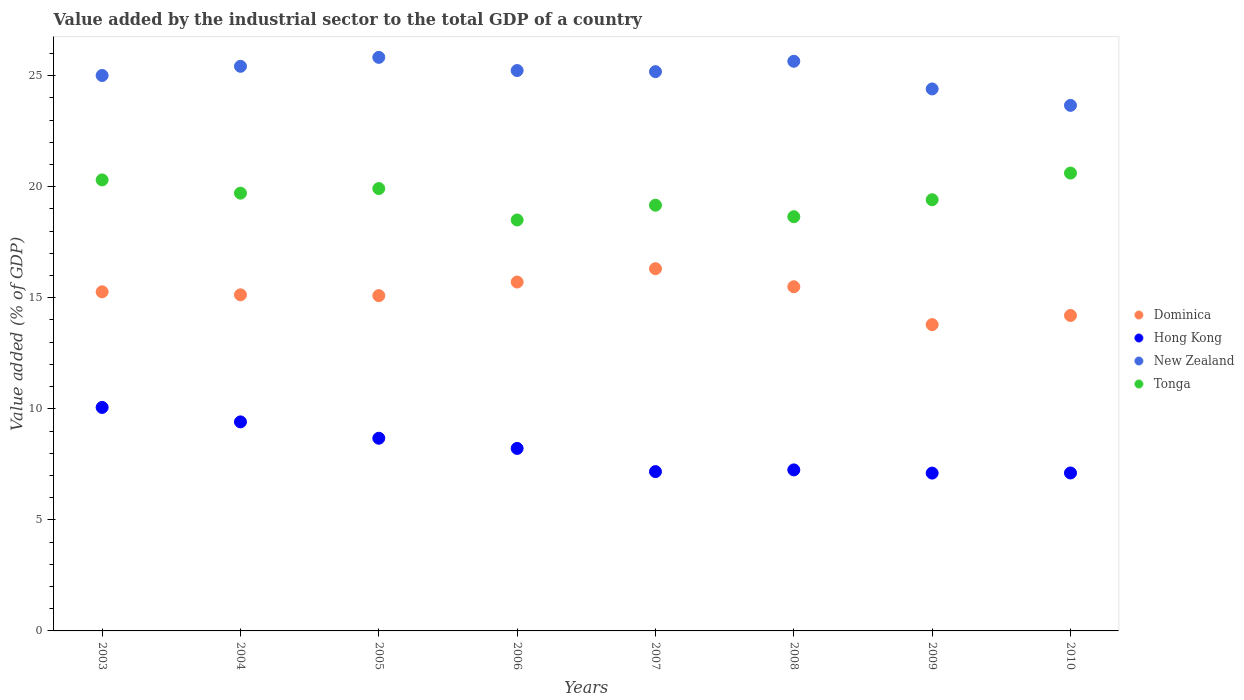What is the value added by the industrial sector to the total GDP in Dominica in 2004?
Provide a succinct answer. 15.13. Across all years, what is the maximum value added by the industrial sector to the total GDP in Dominica?
Your answer should be compact. 16.31. Across all years, what is the minimum value added by the industrial sector to the total GDP in Tonga?
Ensure brevity in your answer.  18.5. In which year was the value added by the industrial sector to the total GDP in New Zealand maximum?
Your answer should be compact. 2005. What is the total value added by the industrial sector to the total GDP in Dominica in the graph?
Your response must be concise. 120.99. What is the difference between the value added by the industrial sector to the total GDP in Dominica in 2008 and that in 2009?
Make the answer very short. 1.7. What is the difference between the value added by the industrial sector to the total GDP in Hong Kong in 2003 and the value added by the industrial sector to the total GDP in New Zealand in 2010?
Give a very brief answer. -13.6. What is the average value added by the industrial sector to the total GDP in New Zealand per year?
Make the answer very short. 25.04. In the year 2007, what is the difference between the value added by the industrial sector to the total GDP in New Zealand and value added by the industrial sector to the total GDP in Hong Kong?
Your answer should be compact. 18.01. What is the ratio of the value added by the industrial sector to the total GDP in Tonga in 2005 to that in 2006?
Offer a terse response. 1.08. Is the value added by the industrial sector to the total GDP in Tonga in 2005 less than that in 2009?
Your answer should be compact. No. Is the difference between the value added by the industrial sector to the total GDP in New Zealand in 2003 and 2008 greater than the difference between the value added by the industrial sector to the total GDP in Hong Kong in 2003 and 2008?
Keep it short and to the point. No. What is the difference between the highest and the second highest value added by the industrial sector to the total GDP in Dominica?
Provide a short and direct response. 0.6. What is the difference between the highest and the lowest value added by the industrial sector to the total GDP in Tonga?
Your response must be concise. 2.11. In how many years, is the value added by the industrial sector to the total GDP in Tonga greater than the average value added by the industrial sector to the total GDP in Tonga taken over all years?
Provide a succinct answer. 4. Is it the case that in every year, the sum of the value added by the industrial sector to the total GDP in Dominica and value added by the industrial sector to the total GDP in Hong Kong  is greater than the value added by the industrial sector to the total GDP in New Zealand?
Provide a short and direct response. No. Is the value added by the industrial sector to the total GDP in Tonga strictly greater than the value added by the industrial sector to the total GDP in Dominica over the years?
Keep it short and to the point. Yes. Is the value added by the industrial sector to the total GDP in New Zealand strictly less than the value added by the industrial sector to the total GDP in Dominica over the years?
Keep it short and to the point. No. How many dotlines are there?
Give a very brief answer. 4. How many years are there in the graph?
Keep it short and to the point. 8. What is the difference between two consecutive major ticks on the Y-axis?
Offer a very short reply. 5. Are the values on the major ticks of Y-axis written in scientific E-notation?
Provide a succinct answer. No. Does the graph contain grids?
Provide a short and direct response. No. How many legend labels are there?
Provide a succinct answer. 4. How are the legend labels stacked?
Keep it short and to the point. Vertical. What is the title of the graph?
Your response must be concise. Value added by the industrial sector to the total GDP of a country. Does "Equatorial Guinea" appear as one of the legend labels in the graph?
Provide a succinct answer. No. What is the label or title of the X-axis?
Your answer should be compact. Years. What is the label or title of the Y-axis?
Provide a succinct answer. Value added (% of GDP). What is the Value added (% of GDP) of Dominica in 2003?
Provide a succinct answer. 15.27. What is the Value added (% of GDP) in Hong Kong in 2003?
Provide a short and direct response. 10.06. What is the Value added (% of GDP) in New Zealand in 2003?
Keep it short and to the point. 25.01. What is the Value added (% of GDP) in Tonga in 2003?
Your answer should be compact. 20.3. What is the Value added (% of GDP) in Dominica in 2004?
Offer a terse response. 15.13. What is the Value added (% of GDP) of Hong Kong in 2004?
Your answer should be compact. 9.41. What is the Value added (% of GDP) in New Zealand in 2004?
Give a very brief answer. 25.42. What is the Value added (% of GDP) of Tonga in 2004?
Your response must be concise. 19.71. What is the Value added (% of GDP) in Dominica in 2005?
Offer a terse response. 15.09. What is the Value added (% of GDP) of Hong Kong in 2005?
Offer a terse response. 8.67. What is the Value added (% of GDP) in New Zealand in 2005?
Make the answer very short. 25.82. What is the Value added (% of GDP) of Tonga in 2005?
Give a very brief answer. 19.92. What is the Value added (% of GDP) of Dominica in 2006?
Give a very brief answer. 15.71. What is the Value added (% of GDP) in Hong Kong in 2006?
Ensure brevity in your answer.  8.22. What is the Value added (% of GDP) of New Zealand in 2006?
Your answer should be compact. 25.23. What is the Value added (% of GDP) in Tonga in 2006?
Offer a terse response. 18.5. What is the Value added (% of GDP) in Dominica in 2007?
Give a very brief answer. 16.31. What is the Value added (% of GDP) of Hong Kong in 2007?
Provide a succinct answer. 7.17. What is the Value added (% of GDP) of New Zealand in 2007?
Ensure brevity in your answer.  25.18. What is the Value added (% of GDP) of Tonga in 2007?
Your response must be concise. 19.17. What is the Value added (% of GDP) of Dominica in 2008?
Give a very brief answer. 15.49. What is the Value added (% of GDP) in Hong Kong in 2008?
Ensure brevity in your answer.  7.25. What is the Value added (% of GDP) of New Zealand in 2008?
Your answer should be compact. 25.65. What is the Value added (% of GDP) in Tonga in 2008?
Offer a very short reply. 18.65. What is the Value added (% of GDP) of Dominica in 2009?
Make the answer very short. 13.79. What is the Value added (% of GDP) in Hong Kong in 2009?
Provide a short and direct response. 7.11. What is the Value added (% of GDP) in New Zealand in 2009?
Offer a very short reply. 24.4. What is the Value added (% of GDP) of Tonga in 2009?
Give a very brief answer. 19.41. What is the Value added (% of GDP) in Dominica in 2010?
Give a very brief answer. 14.2. What is the Value added (% of GDP) of Hong Kong in 2010?
Make the answer very short. 7.11. What is the Value added (% of GDP) in New Zealand in 2010?
Provide a succinct answer. 23.66. What is the Value added (% of GDP) of Tonga in 2010?
Provide a short and direct response. 20.61. Across all years, what is the maximum Value added (% of GDP) of Dominica?
Your answer should be very brief. 16.31. Across all years, what is the maximum Value added (% of GDP) of Hong Kong?
Your response must be concise. 10.06. Across all years, what is the maximum Value added (% of GDP) of New Zealand?
Offer a terse response. 25.82. Across all years, what is the maximum Value added (% of GDP) in Tonga?
Provide a succinct answer. 20.61. Across all years, what is the minimum Value added (% of GDP) of Dominica?
Provide a succinct answer. 13.79. Across all years, what is the minimum Value added (% of GDP) in Hong Kong?
Provide a short and direct response. 7.11. Across all years, what is the minimum Value added (% of GDP) in New Zealand?
Give a very brief answer. 23.66. Across all years, what is the minimum Value added (% of GDP) of Tonga?
Make the answer very short. 18.5. What is the total Value added (% of GDP) of Dominica in the graph?
Your response must be concise. 120.99. What is the total Value added (% of GDP) of Hong Kong in the graph?
Your answer should be compact. 65. What is the total Value added (% of GDP) in New Zealand in the graph?
Your response must be concise. 200.36. What is the total Value added (% of GDP) in Tonga in the graph?
Offer a very short reply. 156.27. What is the difference between the Value added (% of GDP) in Dominica in 2003 and that in 2004?
Your answer should be compact. 0.14. What is the difference between the Value added (% of GDP) of Hong Kong in 2003 and that in 2004?
Offer a very short reply. 0.65. What is the difference between the Value added (% of GDP) of New Zealand in 2003 and that in 2004?
Keep it short and to the point. -0.41. What is the difference between the Value added (% of GDP) in Tonga in 2003 and that in 2004?
Ensure brevity in your answer.  0.6. What is the difference between the Value added (% of GDP) in Dominica in 2003 and that in 2005?
Your answer should be compact. 0.17. What is the difference between the Value added (% of GDP) in Hong Kong in 2003 and that in 2005?
Ensure brevity in your answer.  1.39. What is the difference between the Value added (% of GDP) of New Zealand in 2003 and that in 2005?
Your answer should be very brief. -0.82. What is the difference between the Value added (% of GDP) in Tonga in 2003 and that in 2005?
Offer a very short reply. 0.39. What is the difference between the Value added (% of GDP) of Dominica in 2003 and that in 2006?
Offer a very short reply. -0.44. What is the difference between the Value added (% of GDP) in Hong Kong in 2003 and that in 2006?
Give a very brief answer. 1.85. What is the difference between the Value added (% of GDP) of New Zealand in 2003 and that in 2006?
Offer a very short reply. -0.22. What is the difference between the Value added (% of GDP) of Tonga in 2003 and that in 2006?
Provide a succinct answer. 1.8. What is the difference between the Value added (% of GDP) in Dominica in 2003 and that in 2007?
Your response must be concise. -1.04. What is the difference between the Value added (% of GDP) of Hong Kong in 2003 and that in 2007?
Make the answer very short. 2.89. What is the difference between the Value added (% of GDP) in New Zealand in 2003 and that in 2007?
Provide a short and direct response. -0.17. What is the difference between the Value added (% of GDP) of Tonga in 2003 and that in 2007?
Make the answer very short. 1.14. What is the difference between the Value added (% of GDP) in Dominica in 2003 and that in 2008?
Keep it short and to the point. -0.23. What is the difference between the Value added (% of GDP) of Hong Kong in 2003 and that in 2008?
Your response must be concise. 2.81. What is the difference between the Value added (% of GDP) in New Zealand in 2003 and that in 2008?
Keep it short and to the point. -0.64. What is the difference between the Value added (% of GDP) in Tonga in 2003 and that in 2008?
Offer a very short reply. 1.66. What is the difference between the Value added (% of GDP) in Dominica in 2003 and that in 2009?
Your answer should be compact. 1.48. What is the difference between the Value added (% of GDP) in Hong Kong in 2003 and that in 2009?
Ensure brevity in your answer.  2.96. What is the difference between the Value added (% of GDP) of New Zealand in 2003 and that in 2009?
Ensure brevity in your answer.  0.61. What is the difference between the Value added (% of GDP) in Tonga in 2003 and that in 2009?
Your response must be concise. 0.89. What is the difference between the Value added (% of GDP) of Dominica in 2003 and that in 2010?
Ensure brevity in your answer.  1.07. What is the difference between the Value added (% of GDP) of Hong Kong in 2003 and that in 2010?
Give a very brief answer. 2.95. What is the difference between the Value added (% of GDP) of New Zealand in 2003 and that in 2010?
Provide a short and direct response. 1.34. What is the difference between the Value added (% of GDP) in Tonga in 2003 and that in 2010?
Your answer should be very brief. -0.31. What is the difference between the Value added (% of GDP) of Dominica in 2004 and that in 2005?
Provide a short and direct response. 0.04. What is the difference between the Value added (% of GDP) of Hong Kong in 2004 and that in 2005?
Provide a short and direct response. 0.74. What is the difference between the Value added (% of GDP) of New Zealand in 2004 and that in 2005?
Provide a short and direct response. -0.4. What is the difference between the Value added (% of GDP) in Tonga in 2004 and that in 2005?
Offer a terse response. -0.21. What is the difference between the Value added (% of GDP) in Dominica in 2004 and that in 2006?
Provide a succinct answer. -0.58. What is the difference between the Value added (% of GDP) of Hong Kong in 2004 and that in 2006?
Give a very brief answer. 1.19. What is the difference between the Value added (% of GDP) in New Zealand in 2004 and that in 2006?
Offer a terse response. 0.19. What is the difference between the Value added (% of GDP) of Tonga in 2004 and that in 2006?
Give a very brief answer. 1.21. What is the difference between the Value added (% of GDP) of Dominica in 2004 and that in 2007?
Provide a short and direct response. -1.18. What is the difference between the Value added (% of GDP) of Hong Kong in 2004 and that in 2007?
Your answer should be compact. 2.24. What is the difference between the Value added (% of GDP) of New Zealand in 2004 and that in 2007?
Your response must be concise. 0.24. What is the difference between the Value added (% of GDP) in Tonga in 2004 and that in 2007?
Your answer should be very brief. 0.54. What is the difference between the Value added (% of GDP) in Dominica in 2004 and that in 2008?
Make the answer very short. -0.36. What is the difference between the Value added (% of GDP) in Hong Kong in 2004 and that in 2008?
Your answer should be very brief. 2.16. What is the difference between the Value added (% of GDP) in New Zealand in 2004 and that in 2008?
Your response must be concise. -0.23. What is the difference between the Value added (% of GDP) in Tonga in 2004 and that in 2008?
Provide a short and direct response. 1.06. What is the difference between the Value added (% of GDP) of Dominica in 2004 and that in 2009?
Offer a terse response. 1.34. What is the difference between the Value added (% of GDP) in Hong Kong in 2004 and that in 2009?
Provide a short and direct response. 2.31. What is the difference between the Value added (% of GDP) in New Zealand in 2004 and that in 2009?
Offer a very short reply. 1.02. What is the difference between the Value added (% of GDP) of Tonga in 2004 and that in 2009?
Your answer should be very brief. 0.3. What is the difference between the Value added (% of GDP) in Dominica in 2004 and that in 2010?
Offer a terse response. 0.93. What is the difference between the Value added (% of GDP) in New Zealand in 2004 and that in 2010?
Provide a succinct answer. 1.76. What is the difference between the Value added (% of GDP) of Tonga in 2004 and that in 2010?
Give a very brief answer. -0.9. What is the difference between the Value added (% of GDP) in Dominica in 2005 and that in 2006?
Ensure brevity in your answer.  -0.61. What is the difference between the Value added (% of GDP) of Hong Kong in 2005 and that in 2006?
Make the answer very short. 0.46. What is the difference between the Value added (% of GDP) of New Zealand in 2005 and that in 2006?
Ensure brevity in your answer.  0.59. What is the difference between the Value added (% of GDP) in Tonga in 2005 and that in 2006?
Ensure brevity in your answer.  1.42. What is the difference between the Value added (% of GDP) in Dominica in 2005 and that in 2007?
Offer a very short reply. -1.21. What is the difference between the Value added (% of GDP) in Hong Kong in 2005 and that in 2007?
Give a very brief answer. 1.5. What is the difference between the Value added (% of GDP) of New Zealand in 2005 and that in 2007?
Offer a terse response. 0.64. What is the difference between the Value added (% of GDP) of Tonga in 2005 and that in 2007?
Offer a very short reply. 0.75. What is the difference between the Value added (% of GDP) of Dominica in 2005 and that in 2008?
Give a very brief answer. -0.4. What is the difference between the Value added (% of GDP) of Hong Kong in 2005 and that in 2008?
Provide a short and direct response. 1.43. What is the difference between the Value added (% of GDP) of New Zealand in 2005 and that in 2008?
Provide a succinct answer. 0.18. What is the difference between the Value added (% of GDP) of Tonga in 2005 and that in 2008?
Your answer should be very brief. 1.27. What is the difference between the Value added (% of GDP) of Dominica in 2005 and that in 2009?
Provide a succinct answer. 1.3. What is the difference between the Value added (% of GDP) of Hong Kong in 2005 and that in 2009?
Your answer should be compact. 1.57. What is the difference between the Value added (% of GDP) of New Zealand in 2005 and that in 2009?
Give a very brief answer. 1.42. What is the difference between the Value added (% of GDP) in Tonga in 2005 and that in 2009?
Ensure brevity in your answer.  0.5. What is the difference between the Value added (% of GDP) in Dominica in 2005 and that in 2010?
Your answer should be compact. 0.89. What is the difference between the Value added (% of GDP) of Hong Kong in 2005 and that in 2010?
Offer a very short reply. 1.56. What is the difference between the Value added (% of GDP) in New Zealand in 2005 and that in 2010?
Provide a short and direct response. 2.16. What is the difference between the Value added (% of GDP) of Tonga in 2005 and that in 2010?
Your answer should be compact. -0.7. What is the difference between the Value added (% of GDP) of Dominica in 2006 and that in 2007?
Your response must be concise. -0.6. What is the difference between the Value added (% of GDP) in Hong Kong in 2006 and that in 2007?
Your response must be concise. 1.04. What is the difference between the Value added (% of GDP) in New Zealand in 2006 and that in 2007?
Provide a short and direct response. 0.05. What is the difference between the Value added (% of GDP) in Tonga in 2006 and that in 2007?
Ensure brevity in your answer.  -0.67. What is the difference between the Value added (% of GDP) of Dominica in 2006 and that in 2008?
Offer a terse response. 0.21. What is the difference between the Value added (% of GDP) of New Zealand in 2006 and that in 2008?
Make the answer very short. -0.42. What is the difference between the Value added (% of GDP) in Tonga in 2006 and that in 2008?
Offer a terse response. -0.15. What is the difference between the Value added (% of GDP) in Dominica in 2006 and that in 2009?
Your answer should be compact. 1.92. What is the difference between the Value added (% of GDP) of Hong Kong in 2006 and that in 2009?
Give a very brief answer. 1.11. What is the difference between the Value added (% of GDP) in New Zealand in 2006 and that in 2009?
Offer a very short reply. 0.83. What is the difference between the Value added (% of GDP) in Tonga in 2006 and that in 2009?
Offer a very short reply. -0.91. What is the difference between the Value added (% of GDP) of Dominica in 2006 and that in 2010?
Offer a terse response. 1.51. What is the difference between the Value added (% of GDP) in Hong Kong in 2006 and that in 2010?
Your answer should be very brief. 1.11. What is the difference between the Value added (% of GDP) of New Zealand in 2006 and that in 2010?
Provide a short and direct response. 1.57. What is the difference between the Value added (% of GDP) in Tonga in 2006 and that in 2010?
Offer a very short reply. -2.11. What is the difference between the Value added (% of GDP) of Dominica in 2007 and that in 2008?
Offer a very short reply. 0.81. What is the difference between the Value added (% of GDP) in Hong Kong in 2007 and that in 2008?
Your response must be concise. -0.08. What is the difference between the Value added (% of GDP) of New Zealand in 2007 and that in 2008?
Provide a succinct answer. -0.47. What is the difference between the Value added (% of GDP) in Tonga in 2007 and that in 2008?
Your response must be concise. 0.52. What is the difference between the Value added (% of GDP) of Dominica in 2007 and that in 2009?
Your response must be concise. 2.52. What is the difference between the Value added (% of GDP) in Hong Kong in 2007 and that in 2009?
Give a very brief answer. 0.07. What is the difference between the Value added (% of GDP) of New Zealand in 2007 and that in 2009?
Give a very brief answer. 0.78. What is the difference between the Value added (% of GDP) of Tonga in 2007 and that in 2009?
Your answer should be very brief. -0.25. What is the difference between the Value added (% of GDP) in Dominica in 2007 and that in 2010?
Provide a short and direct response. 2.11. What is the difference between the Value added (% of GDP) of Hong Kong in 2007 and that in 2010?
Offer a terse response. 0.06. What is the difference between the Value added (% of GDP) in New Zealand in 2007 and that in 2010?
Your response must be concise. 1.52. What is the difference between the Value added (% of GDP) of Tonga in 2007 and that in 2010?
Your answer should be very brief. -1.45. What is the difference between the Value added (% of GDP) of Dominica in 2008 and that in 2009?
Provide a succinct answer. 1.7. What is the difference between the Value added (% of GDP) of Hong Kong in 2008 and that in 2009?
Your answer should be very brief. 0.14. What is the difference between the Value added (% of GDP) in New Zealand in 2008 and that in 2009?
Ensure brevity in your answer.  1.25. What is the difference between the Value added (% of GDP) of Tonga in 2008 and that in 2009?
Provide a succinct answer. -0.76. What is the difference between the Value added (% of GDP) in Dominica in 2008 and that in 2010?
Provide a short and direct response. 1.29. What is the difference between the Value added (% of GDP) in Hong Kong in 2008 and that in 2010?
Give a very brief answer. 0.14. What is the difference between the Value added (% of GDP) of New Zealand in 2008 and that in 2010?
Keep it short and to the point. 1.98. What is the difference between the Value added (% of GDP) in Tonga in 2008 and that in 2010?
Offer a very short reply. -1.96. What is the difference between the Value added (% of GDP) of Dominica in 2009 and that in 2010?
Ensure brevity in your answer.  -0.41. What is the difference between the Value added (% of GDP) of Hong Kong in 2009 and that in 2010?
Offer a terse response. -0.01. What is the difference between the Value added (% of GDP) in New Zealand in 2009 and that in 2010?
Your response must be concise. 0.74. What is the difference between the Value added (% of GDP) of Tonga in 2009 and that in 2010?
Provide a succinct answer. -1.2. What is the difference between the Value added (% of GDP) in Dominica in 2003 and the Value added (% of GDP) in Hong Kong in 2004?
Offer a terse response. 5.86. What is the difference between the Value added (% of GDP) of Dominica in 2003 and the Value added (% of GDP) of New Zealand in 2004?
Your answer should be compact. -10.15. What is the difference between the Value added (% of GDP) of Dominica in 2003 and the Value added (% of GDP) of Tonga in 2004?
Make the answer very short. -4.44. What is the difference between the Value added (% of GDP) of Hong Kong in 2003 and the Value added (% of GDP) of New Zealand in 2004?
Ensure brevity in your answer.  -15.36. What is the difference between the Value added (% of GDP) of Hong Kong in 2003 and the Value added (% of GDP) of Tonga in 2004?
Offer a very short reply. -9.65. What is the difference between the Value added (% of GDP) in New Zealand in 2003 and the Value added (% of GDP) in Tonga in 2004?
Your answer should be very brief. 5.3. What is the difference between the Value added (% of GDP) of Dominica in 2003 and the Value added (% of GDP) of Hong Kong in 2005?
Ensure brevity in your answer.  6.59. What is the difference between the Value added (% of GDP) of Dominica in 2003 and the Value added (% of GDP) of New Zealand in 2005?
Make the answer very short. -10.56. What is the difference between the Value added (% of GDP) in Dominica in 2003 and the Value added (% of GDP) in Tonga in 2005?
Your answer should be very brief. -4.65. What is the difference between the Value added (% of GDP) of Hong Kong in 2003 and the Value added (% of GDP) of New Zealand in 2005?
Your answer should be very brief. -15.76. What is the difference between the Value added (% of GDP) of Hong Kong in 2003 and the Value added (% of GDP) of Tonga in 2005?
Give a very brief answer. -9.85. What is the difference between the Value added (% of GDP) of New Zealand in 2003 and the Value added (% of GDP) of Tonga in 2005?
Your answer should be very brief. 5.09. What is the difference between the Value added (% of GDP) in Dominica in 2003 and the Value added (% of GDP) in Hong Kong in 2006?
Offer a very short reply. 7.05. What is the difference between the Value added (% of GDP) in Dominica in 2003 and the Value added (% of GDP) in New Zealand in 2006?
Offer a terse response. -9.96. What is the difference between the Value added (% of GDP) of Dominica in 2003 and the Value added (% of GDP) of Tonga in 2006?
Your answer should be compact. -3.23. What is the difference between the Value added (% of GDP) of Hong Kong in 2003 and the Value added (% of GDP) of New Zealand in 2006?
Provide a short and direct response. -15.17. What is the difference between the Value added (% of GDP) in Hong Kong in 2003 and the Value added (% of GDP) in Tonga in 2006?
Your answer should be very brief. -8.44. What is the difference between the Value added (% of GDP) of New Zealand in 2003 and the Value added (% of GDP) of Tonga in 2006?
Offer a terse response. 6.5. What is the difference between the Value added (% of GDP) in Dominica in 2003 and the Value added (% of GDP) in Hong Kong in 2007?
Make the answer very short. 8.09. What is the difference between the Value added (% of GDP) of Dominica in 2003 and the Value added (% of GDP) of New Zealand in 2007?
Your answer should be very brief. -9.91. What is the difference between the Value added (% of GDP) in Dominica in 2003 and the Value added (% of GDP) in Tonga in 2007?
Make the answer very short. -3.9. What is the difference between the Value added (% of GDP) of Hong Kong in 2003 and the Value added (% of GDP) of New Zealand in 2007?
Provide a short and direct response. -15.12. What is the difference between the Value added (% of GDP) of Hong Kong in 2003 and the Value added (% of GDP) of Tonga in 2007?
Ensure brevity in your answer.  -9.1. What is the difference between the Value added (% of GDP) of New Zealand in 2003 and the Value added (% of GDP) of Tonga in 2007?
Ensure brevity in your answer.  5.84. What is the difference between the Value added (% of GDP) in Dominica in 2003 and the Value added (% of GDP) in Hong Kong in 2008?
Offer a terse response. 8.02. What is the difference between the Value added (% of GDP) of Dominica in 2003 and the Value added (% of GDP) of New Zealand in 2008?
Your response must be concise. -10.38. What is the difference between the Value added (% of GDP) in Dominica in 2003 and the Value added (% of GDP) in Tonga in 2008?
Your answer should be compact. -3.38. What is the difference between the Value added (% of GDP) in Hong Kong in 2003 and the Value added (% of GDP) in New Zealand in 2008?
Ensure brevity in your answer.  -15.58. What is the difference between the Value added (% of GDP) in Hong Kong in 2003 and the Value added (% of GDP) in Tonga in 2008?
Your answer should be very brief. -8.59. What is the difference between the Value added (% of GDP) of New Zealand in 2003 and the Value added (% of GDP) of Tonga in 2008?
Keep it short and to the point. 6.36. What is the difference between the Value added (% of GDP) in Dominica in 2003 and the Value added (% of GDP) in Hong Kong in 2009?
Provide a short and direct response. 8.16. What is the difference between the Value added (% of GDP) in Dominica in 2003 and the Value added (% of GDP) in New Zealand in 2009?
Give a very brief answer. -9.13. What is the difference between the Value added (% of GDP) of Dominica in 2003 and the Value added (% of GDP) of Tonga in 2009?
Offer a terse response. -4.15. What is the difference between the Value added (% of GDP) in Hong Kong in 2003 and the Value added (% of GDP) in New Zealand in 2009?
Ensure brevity in your answer.  -14.34. What is the difference between the Value added (% of GDP) in Hong Kong in 2003 and the Value added (% of GDP) in Tonga in 2009?
Your answer should be very brief. -9.35. What is the difference between the Value added (% of GDP) in New Zealand in 2003 and the Value added (% of GDP) in Tonga in 2009?
Keep it short and to the point. 5.59. What is the difference between the Value added (% of GDP) in Dominica in 2003 and the Value added (% of GDP) in Hong Kong in 2010?
Provide a succinct answer. 8.16. What is the difference between the Value added (% of GDP) of Dominica in 2003 and the Value added (% of GDP) of New Zealand in 2010?
Your answer should be compact. -8.39. What is the difference between the Value added (% of GDP) in Dominica in 2003 and the Value added (% of GDP) in Tonga in 2010?
Your answer should be compact. -5.35. What is the difference between the Value added (% of GDP) of Hong Kong in 2003 and the Value added (% of GDP) of New Zealand in 2010?
Provide a short and direct response. -13.6. What is the difference between the Value added (% of GDP) of Hong Kong in 2003 and the Value added (% of GDP) of Tonga in 2010?
Your answer should be very brief. -10.55. What is the difference between the Value added (% of GDP) of New Zealand in 2003 and the Value added (% of GDP) of Tonga in 2010?
Provide a short and direct response. 4.39. What is the difference between the Value added (% of GDP) in Dominica in 2004 and the Value added (% of GDP) in Hong Kong in 2005?
Your response must be concise. 6.46. What is the difference between the Value added (% of GDP) in Dominica in 2004 and the Value added (% of GDP) in New Zealand in 2005?
Keep it short and to the point. -10.69. What is the difference between the Value added (% of GDP) in Dominica in 2004 and the Value added (% of GDP) in Tonga in 2005?
Your answer should be very brief. -4.78. What is the difference between the Value added (% of GDP) of Hong Kong in 2004 and the Value added (% of GDP) of New Zealand in 2005?
Offer a terse response. -16.41. What is the difference between the Value added (% of GDP) of Hong Kong in 2004 and the Value added (% of GDP) of Tonga in 2005?
Your answer should be compact. -10.5. What is the difference between the Value added (% of GDP) in New Zealand in 2004 and the Value added (% of GDP) in Tonga in 2005?
Your answer should be very brief. 5.5. What is the difference between the Value added (% of GDP) in Dominica in 2004 and the Value added (% of GDP) in Hong Kong in 2006?
Make the answer very short. 6.91. What is the difference between the Value added (% of GDP) of Dominica in 2004 and the Value added (% of GDP) of New Zealand in 2006?
Offer a very short reply. -10.1. What is the difference between the Value added (% of GDP) in Dominica in 2004 and the Value added (% of GDP) in Tonga in 2006?
Offer a very short reply. -3.37. What is the difference between the Value added (% of GDP) of Hong Kong in 2004 and the Value added (% of GDP) of New Zealand in 2006?
Offer a very short reply. -15.82. What is the difference between the Value added (% of GDP) in Hong Kong in 2004 and the Value added (% of GDP) in Tonga in 2006?
Ensure brevity in your answer.  -9.09. What is the difference between the Value added (% of GDP) of New Zealand in 2004 and the Value added (% of GDP) of Tonga in 2006?
Your response must be concise. 6.92. What is the difference between the Value added (% of GDP) of Dominica in 2004 and the Value added (% of GDP) of Hong Kong in 2007?
Give a very brief answer. 7.96. What is the difference between the Value added (% of GDP) of Dominica in 2004 and the Value added (% of GDP) of New Zealand in 2007?
Provide a short and direct response. -10.05. What is the difference between the Value added (% of GDP) of Dominica in 2004 and the Value added (% of GDP) of Tonga in 2007?
Provide a succinct answer. -4.03. What is the difference between the Value added (% of GDP) in Hong Kong in 2004 and the Value added (% of GDP) in New Zealand in 2007?
Ensure brevity in your answer.  -15.77. What is the difference between the Value added (% of GDP) of Hong Kong in 2004 and the Value added (% of GDP) of Tonga in 2007?
Ensure brevity in your answer.  -9.75. What is the difference between the Value added (% of GDP) of New Zealand in 2004 and the Value added (% of GDP) of Tonga in 2007?
Provide a short and direct response. 6.25. What is the difference between the Value added (% of GDP) of Dominica in 2004 and the Value added (% of GDP) of Hong Kong in 2008?
Your answer should be very brief. 7.88. What is the difference between the Value added (% of GDP) in Dominica in 2004 and the Value added (% of GDP) in New Zealand in 2008?
Offer a terse response. -10.51. What is the difference between the Value added (% of GDP) in Dominica in 2004 and the Value added (% of GDP) in Tonga in 2008?
Keep it short and to the point. -3.52. What is the difference between the Value added (% of GDP) of Hong Kong in 2004 and the Value added (% of GDP) of New Zealand in 2008?
Give a very brief answer. -16.23. What is the difference between the Value added (% of GDP) of Hong Kong in 2004 and the Value added (% of GDP) of Tonga in 2008?
Your answer should be compact. -9.24. What is the difference between the Value added (% of GDP) of New Zealand in 2004 and the Value added (% of GDP) of Tonga in 2008?
Your response must be concise. 6.77. What is the difference between the Value added (% of GDP) of Dominica in 2004 and the Value added (% of GDP) of Hong Kong in 2009?
Your answer should be very brief. 8.03. What is the difference between the Value added (% of GDP) in Dominica in 2004 and the Value added (% of GDP) in New Zealand in 2009?
Your response must be concise. -9.27. What is the difference between the Value added (% of GDP) of Dominica in 2004 and the Value added (% of GDP) of Tonga in 2009?
Your answer should be very brief. -4.28. What is the difference between the Value added (% of GDP) of Hong Kong in 2004 and the Value added (% of GDP) of New Zealand in 2009?
Give a very brief answer. -14.99. What is the difference between the Value added (% of GDP) of Hong Kong in 2004 and the Value added (% of GDP) of Tonga in 2009?
Provide a short and direct response. -10. What is the difference between the Value added (% of GDP) in New Zealand in 2004 and the Value added (% of GDP) in Tonga in 2009?
Ensure brevity in your answer.  6.01. What is the difference between the Value added (% of GDP) in Dominica in 2004 and the Value added (% of GDP) in Hong Kong in 2010?
Provide a short and direct response. 8.02. What is the difference between the Value added (% of GDP) of Dominica in 2004 and the Value added (% of GDP) of New Zealand in 2010?
Offer a terse response. -8.53. What is the difference between the Value added (% of GDP) in Dominica in 2004 and the Value added (% of GDP) in Tonga in 2010?
Offer a terse response. -5.48. What is the difference between the Value added (% of GDP) of Hong Kong in 2004 and the Value added (% of GDP) of New Zealand in 2010?
Make the answer very short. -14.25. What is the difference between the Value added (% of GDP) in Hong Kong in 2004 and the Value added (% of GDP) in Tonga in 2010?
Your answer should be compact. -11.2. What is the difference between the Value added (% of GDP) of New Zealand in 2004 and the Value added (% of GDP) of Tonga in 2010?
Provide a short and direct response. 4.81. What is the difference between the Value added (% of GDP) of Dominica in 2005 and the Value added (% of GDP) of Hong Kong in 2006?
Offer a very short reply. 6.88. What is the difference between the Value added (% of GDP) of Dominica in 2005 and the Value added (% of GDP) of New Zealand in 2006?
Give a very brief answer. -10.13. What is the difference between the Value added (% of GDP) of Dominica in 2005 and the Value added (% of GDP) of Tonga in 2006?
Provide a short and direct response. -3.41. What is the difference between the Value added (% of GDP) of Hong Kong in 2005 and the Value added (% of GDP) of New Zealand in 2006?
Provide a succinct answer. -16.55. What is the difference between the Value added (% of GDP) of Hong Kong in 2005 and the Value added (% of GDP) of Tonga in 2006?
Your answer should be very brief. -9.83. What is the difference between the Value added (% of GDP) of New Zealand in 2005 and the Value added (% of GDP) of Tonga in 2006?
Offer a very short reply. 7.32. What is the difference between the Value added (% of GDP) in Dominica in 2005 and the Value added (% of GDP) in Hong Kong in 2007?
Provide a short and direct response. 7.92. What is the difference between the Value added (% of GDP) of Dominica in 2005 and the Value added (% of GDP) of New Zealand in 2007?
Offer a very short reply. -10.08. What is the difference between the Value added (% of GDP) in Dominica in 2005 and the Value added (% of GDP) in Tonga in 2007?
Make the answer very short. -4.07. What is the difference between the Value added (% of GDP) of Hong Kong in 2005 and the Value added (% of GDP) of New Zealand in 2007?
Keep it short and to the point. -16.5. What is the difference between the Value added (% of GDP) in Hong Kong in 2005 and the Value added (% of GDP) in Tonga in 2007?
Give a very brief answer. -10.49. What is the difference between the Value added (% of GDP) of New Zealand in 2005 and the Value added (% of GDP) of Tonga in 2007?
Ensure brevity in your answer.  6.66. What is the difference between the Value added (% of GDP) in Dominica in 2005 and the Value added (% of GDP) in Hong Kong in 2008?
Your response must be concise. 7.84. What is the difference between the Value added (% of GDP) in Dominica in 2005 and the Value added (% of GDP) in New Zealand in 2008?
Provide a succinct answer. -10.55. What is the difference between the Value added (% of GDP) of Dominica in 2005 and the Value added (% of GDP) of Tonga in 2008?
Your answer should be very brief. -3.55. What is the difference between the Value added (% of GDP) of Hong Kong in 2005 and the Value added (% of GDP) of New Zealand in 2008?
Provide a succinct answer. -16.97. What is the difference between the Value added (% of GDP) in Hong Kong in 2005 and the Value added (% of GDP) in Tonga in 2008?
Give a very brief answer. -9.97. What is the difference between the Value added (% of GDP) in New Zealand in 2005 and the Value added (% of GDP) in Tonga in 2008?
Provide a succinct answer. 7.17. What is the difference between the Value added (% of GDP) of Dominica in 2005 and the Value added (% of GDP) of Hong Kong in 2009?
Your answer should be compact. 7.99. What is the difference between the Value added (% of GDP) of Dominica in 2005 and the Value added (% of GDP) of New Zealand in 2009?
Ensure brevity in your answer.  -9.31. What is the difference between the Value added (% of GDP) of Dominica in 2005 and the Value added (% of GDP) of Tonga in 2009?
Offer a very short reply. -4.32. What is the difference between the Value added (% of GDP) of Hong Kong in 2005 and the Value added (% of GDP) of New Zealand in 2009?
Provide a short and direct response. -15.73. What is the difference between the Value added (% of GDP) of Hong Kong in 2005 and the Value added (% of GDP) of Tonga in 2009?
Your answer should be very brief. -10.74. What is the difference between the Value added (% of GDP) in New Zealand in 2005 and the Value added (% of GDP) in Tonga in 2009?
Keep it short and to the point. 6.41. What is the difference between the Value added (% of GDP) in Dominica in 2005 and the Value added (% of GDP) in Hong Kong in 2010?
Provide a short and direct response. 7.98. What is the difference between the Value added (% of GDP) of Dominica in 2005 and the Value added (% of GDP) of New Zealand in 2010?
Your answer should be very brief. -8.57. What is the difference between the Value added (% of GDP) of Dominica in 2005 and the Value added (% of GDP) of Tonga in 2010?
Offer a very short reply. -5.52. What is the difference between the Value added (% of GDP) in Hong Kong in 2005 and the Value added (% of GDP) in New Zealand in 2010?
Your response must be concise. -14.99. What is the difference between the Value added (% of GDP) in Hong Kong in 2005 and the Value added (% of GDP) in Tonga in 2010?
Offer a terse response. -11.94. What is the difference between the Value added (% of GDP) in New Zealand in 2005 and the Value added (% of GDP) in Tonga in 2010?
Provide a succinct answer. 5.21. What is the difference between the Value added (% of GDP) in Dominica in 2006 and the Value added (% of GDP) in Hong Kong in 2007?
Provide a succinct answer. 8.53. What is the difference between the Value added (% of GDP) in Dominica in 2006 and the Value added (% of GDP) in New Zealand in 2007?
Your answer should be very brief. -9.47. What is the difference between the Value added (% of GDP) of Dominica in 2006 and the Value added (% of GDP) of Tonga in 2007?
Offer a terse response. -3.46. What is the difference between the Value added (% of GDP) in Hong Kong in 2006 and the Value added (% of GDP) in New Zealand in 2007?
Provide a short and direct response. -16.96. What is the difference between the Value added (% of GDP) in Hong Kong in 2006 and the Value added (% of GDP) in Tonga in 2007?
Your answer should be compact. -10.95. What is the difference between the Value added (% of GDP) in New Zealand in 2006 and the Value added (% of GDP) in Tonga in 2007?
Keep it short and to the point. 6.06. What is the difference between the Value added (% of GDP) of Dominica in 2006 and the Value added (% of GDP) of Hong Kong in 2008?
Offer a very short reply. 8.46. What is the difference between the Value added (% of GDP) in Dominica in 2006 and the Value added (% of GDP) in New Zealand in 2008?
Offer a terse response. -9.94. What is the difference between the Value added (% of GDP) in Dominica in 2006 and the Value added (% of GDP) in Tonga in 2008?
Provide a succinct answer. -2.94. What is the difference between the Value added (% of GDP) of Hong Kong in 2006 and the Value added (% of GDP) of New Zealand in 2008?
Provide a succinct answer. -17.43. What is the difference between the Value added (% of GDP) in Hong Kong in 2006 and the Value added (% of GDP) in Tonga in 2008?
Provide a succinct answer. -10.43. What is the difference between the Value added (% of GDP) in New Zealand in 2006 and the Value added (% of GDP) in Tonga in 2008?
Provide a short and direct response. 6.58. What is the difference between the Value added (% of GDP) of Dominica in 2006 and the Value added (% of GDP) of Hong Kong in 2009?
Ensure brevity in your answer.  8.6. What is the difference between the Value added (% of GDP) of Dominica in 2006 and the Value added (% of GDP) of New Zealand in 2009?
Provide a short and direct response. -8.69. What is the difference between the Value added (% of GDP) in Dominica in 2006 and the Value added (% of GDP) in Tonga in 2009?
Offer a terse response. -3.71. What is the difference between the Value added (% of GDP) in Hong Kong in 2006 and the Value added (% of GDP) in New Zealand in 2009?
Your answer should be compact. -16.18. What is the difference between the Value added (% of GDP) of Hong Kong in 2006 and the Value added (% of GDP) of Tonga in 2009?
Make the answer very short. -11.2. What is the difference between the Value added (% of GDP) of New Zealand in 2006 and the Value added (% of GDP) of Tonga in 2009?
Offer a very short reply. 5.82. What is the difference between the Value added (% of GDP) in Dominica in 2006 and the Value added (% of GDP) in Hong Kong in 2010?
Your answer should be very brief. 8.6. What is the difference between the Value added (% of GDP) of Dominica in 2006 and the Value added (% of GDP) of New Zealand in 2010?
Give a very brief answer. -7.95. What is the difference between the Value added (% of GDP) in Dominica in 2006 and the Value added (% of GDP) in Tonga in 2010?
Make the answer very short. -4.91. What is the difference between the Value added (% of GDP) of Hong Kong in 2006 and the Value added (% of GDP) of New Zealand in 2010?
Keep it short and to the point. -15.44. What is the difference between the Value added (% of GDP) of Hong Kong in 2006 and the Value added (% of GDP) of Tonga in 2010?
Make the answer very short. -12.4. What is the difference between the Value added (% of GDP) of New Zealand in 2006 and the Value added (% of GDP) of Tonga in 2010?
Ensure brevity in your answer.  4.62. What is the difference between the Value added (% of GDP) in Dominica in 2007 and the Value added (% of GDP) in Hong Kong in 2008?
Your response must be concise. 9.06. What is the difference between the Value added (% of GDP) in Dominica in 2007 and the Value added (% of GDP) in New Zealand in 2008?
Keep it short and to the point. -9.34. What is the difference between the Value added (% of GDP) of Dominica in 2007 and the Value added (% of GDP) of Tonga in 2008?
Your response must be concise. -2.34. What is the difference between the Value added (% of GDP) of Hong Kong in 2007 and the Value added (% of GDP) of New Zealand in 2008?
Keep it short and to the point. -18.47. What is the difference between the Value added (% of GDP) of Hong Kong in 2007 and the Value added (% of GDP) of Tonga in 2008?
Provide a short and direct response. -11.48. What is the difference between the Value added (% of GDP) in New Zealand in 2007 and the Value added (% of GDP) in Tonga in 2008?
Ensure brevity in your answer.  6.53. What is the difference between the Value added (% of GDP) in Dominica in 2007 and the Value added (% of GDP) in Hong Kong in 2009?
Your response must be concise. 9.2. What is the difference between the Value added (% of GDP) of Dominica in 2007 and the Value added (% of GDP) of New Zealand in 2009?
Ensure brevity in your answer.  -8.09. What is the difference between the Value added (% of GDP) in Dominica in 2007 and the Value added (% of GDP) in Tonga in 2009?
Make the answer very short. -3.1. What is the difference between the Value added (% of GDP) in Hong Kong in 2007 and the Value added (% of GDP) in New Zealand in 2009?
Your answer should be compact. -17.23. What is the difference between the Value added (% of GDP) of Hong Kong in 2007 and the Value added (% of GDP) of Tonga in 2009?
Your answer should be very brief. -12.24. What is the difference between the Value added (% of GDP) in New Zealand in 2007 and the Value added (% of GDP) in Tonga in 2009?
Your response must be concise. 5.77. What is the difference between the Value added (% of GDP) in Dominica in 2007 and the Value added (% of GDP) in Hong Kong in 2010?
Provide a succinct answer. 9.2. What is the difference between the Value added (% of GDP) in Dominica in 2007 and the Value added (% of GDP) in New Zealand in 2010?
Provide a succinct answer. -7.35. What is the difference between the Value added (% of GDP) of Dominica in 2007 and the Value added (% of GDP) of Tonga in 2010?
Offer a very short reply. -4.3. What is the difference between the Value added (% of GDP) in Hong Kong in 2007 and the Value added (% of GDP) in New Zealand in 2010?
Make the answer very short. -16.49. What is the difference between the Value added (% of GDP) of Hong Kong in 2007 and the Value added (% of GDP) of Tonga in 2010?
Ensure brevity in your answer.  -13.44. What is the difference between the Value added (% of GDP) of New Zealand in 2007 and the Value added (% of GDP) of Tonga in 2010?
Keep it short and to the point. 4.57. What is the difference between the Value added (% of GDP) in Dominica in 2008 and the Value added (% of GDP) in Hong Kong in 2009?
Make the answer very short. 8.39. What is the difference between the Value added (% of GDP) of Dominica in 2008 and the Value added (% of GDP) of New Zealand in 2009?
Provide a short and direct response. -8.91. What is the difference between the Value added (% of GDP) of Dominica in 2008 and the Value added (% of GDP) of Tonga in 2009?
Provide a short and direct response. -3.92. What is the difference between the Value added (% of GDP) in Hong Kong in 2008 and the Value added (% of GDP) in New Zealand in 2009?
Offer a terse response. -17.15. What is the difference between the Value added (% of GDP) in Hong Kong in 2008 and the Value added (% of GDP) in Tonga in 2009?
Your response must be concise. -12.16. What is the difference between the Value added (% of GDP) of New Zealand in 2008 and the Value added (% of GDP) of Tonga in 2009?
Provide a succinct answer. 6.23. What is the difference between the Value added (% of GDP) of Dominica in 2008 and the Value added (% of GDP) of Hong Kong in 2010?
Make the answer very short. 8.38. What is the difference between the Value added (% of GDP) of Dominica in 2008 and the Value added (% of GDP) of New Zealand in 2010?
Make the answer very short. -8.17. What is the difference between the Value added (% of GDP) of Dominica in 2008 and the Value added (% of GDP) of Tonga in 2010?
Give a very brief answer. -5.12. What is the difference between the Value added (% of GDP) of Hong Kong in 2008 and the Value added (% of GDP) of New Zealand in 2010?
Ensure brevity in your answer.  -16.41. What is the difference between the Value added (% of GDP) of Hong Kong in 2008 and the Value added (% of GDP) of Tonga in 2010?
Keep it short and to the point. -13.36. What is the difference between the Value added (% of GDP) of New Zealand in 2008 and the Value added (% of GDP) of Tonga in 2010?
Your answer should be compact. 5.03. What is the difference between the Value added (% of GDP) of Dominica in 2009 and the Value added (% of GDP) of Hong Kong in 2010?
Give a very brief answer. 6.68. What is the difference between the Value added (% of GDP) of Dominica in 2009 and the Value added (% of GDP) of New Zealand in 2010?
Ensure brevity in your answer.  -9.87. What is the difference between the Value added (% of GDP) in Dominica in 2009 and the Value added (% of GDP) in Tonga in 2010?
Provide a short and direct response. -6.82. What is the difference between the Value added (% of GDP) in Hong Kong in 2009 and the Value added (% of GDP) in New Zealand in 2010?
Keep it short and to the point. -16.55. What is the difference between the Value added (% of GDP) of Hong Kong in 2009 and the Value added (% of GDP) of Tonga in 2010?
Ensure brevity in your answer.  -13.51. What is the difference between the Value added (% of GDP) of New Zealand in 2009 and the Value added (% of GDP) of Tonga in 2010?
Provide a succinct answer. 3.79. What is the average Value added (% of GDP) of Dominica per year?
Give a very brief answer. 15.12. What is the average Value added (% of GDP) in Hong Kong per year?
Your response must be concise. 8.13. What is the average Value added (% of GDP) in New Zealand per year?
Your answer should be very brief. 25.04. What is the average Value added (% of GDP) in Tonga per year?
Offer a very short reply. 19.53. In the year 2003, what is the difference between the Value added (% of GDP) in Dominica and Value added (% of GDP) in Hong Kong?
Keep it short and to the point. 5.2. In the year 2003, what is the difference between the Value added (% of GDP) in Dominica and Value added (% of GDP) in New Zealand?
Keep it short and to the point. -9.74. In the year 2003, what is the difference between the Value added (% of GDP) in Dominica and Value added (% of GDP) in Tonga?
Ensure brevity in your answer.  -5.04. In the year 2003, what is the difference between the Value added (% of GDP) of Hong Kong and Value added (% of GDP) of New Zealand?
Provide a short and direct response. -14.94. In the year 2003, what is the difference between the Value added (% of GDP) in Hong Kong and Value added (% of GDP) in Tonga?
Make the answer very short. -10.24. In the year 2003, what is the difference between the Value added (% of GDP) in New Zealand and Value added (% of GDP) in Tonga?
Offer a very short reply. 4.7. In the year 2004, what is the difference between the Value added (% of GDP) of Dominica and Value added (% of GDP) of Hong Kong?
Provide a short and direct response. 5.72. In the year 2004, what is the difference between the Value added (% of GDP) in Dominica and Value added (% of GDP) in New Zealand?
Ensure brevity in your answer.  -10.29. In the year 2004, what is the difference between the Value added (% of GDP) in Dominica and Value added (% of GDP) in Tonga?
Your answer should be very brief. -4.58. In the year 2004, what is the difference between the Value added (% of GDP) of Hong Kong and Value added (% of GDP) of New Zealand?
Give a very brief answer. -16.01. In the year 2004, what is the difference between the Value added (% of GDP) of Hong Kong and Value added (% of GDP) of Tonga?
Make the answer very short. -10.3. In the year 2004, what is the difference between the Value added (% of GDP) of New Zealand and Value added (% of GDP) of Tonga?
Your answer should be very brief. 5.71. In the year 2005, what is the difference between the Value added (% of GDP) of Dominica and Value added (% of GDP) of Hong Kong?
Your response must be concise. 6.42. In the year 2005, what is the difference between the Value added (% of GDP) in Dominica and Value added (% of GDP) in New Zealand?
Keep it short and to the point. -10.73. In the year 2005, what is the difference between the Value added (% of GDP) in Dominica and Value added (% of GDP) in Tonga?
Your answer should be compact. -4.82. In the year 2005, what is the difference between the Value added (% of GDP) in Hong Kong and Value added (% of GDP) in New Zealand?
Your response must be concise. -17.15. In the year 2005, what is the difference between the Value added (% of GDP) of Hong Kong and Value added (% of GDP) of Tonga?
Ensure brevity in your answer.  -11.24. In the year 2005, what is the difference between the Value added (% of GDP) of New Zealand and Value added (% of GDP) of Tonga?
Make the answer very short. 5.91. In the year 2006, what is the difference between the Value added (% of GDP) of Dominica and Value added (% of GDP) of Hong Kong?
Your answer should be very brief. 7.49. In the year 2006, what is the difference between the Value added (% of GDP) of Dominica and Value added (% of GDP) of New Zealand?
Make the answer very short. -9.52. In the year 2006, what is the difference between the Value added (% of GDP) in Dominica and Value added (% of GDP) in Tonga?
Keep it short and to the point. -2.79. In the year 2006, what is the difference between the Value added (% of GDP) of Hong Kong and Value added (% of GDP) of New Zealand?
Provide a short and direct response. -17.01. In the year 2006, what is the difference between the Value added (% of GDP) of Hong Kong and Value added (% of GDP) of Tonga?
Offer a very short reply. -10.28. In the year 2006, what is the difference between the Value added (% of GDP) in New Zealand and Value added (% of GDP) in Tonga?
Offer a terse response. 6.73. In the year 2007, what is the difference between the Value added (% of GDP) in Dominica and Value added (% of GDP) in Hong Kong?
Your response must be concise. 9.14. In the year 2007, what is the difference between the Value added (% of GDP) in Dominica and Value added (% of GDP) in New Zealand?
Your response must be concise. -8.87. In the year 2007, what is the difference between the Value added (% of GDP) in Dominica and Value added (% of GDP) in Tonga?
Offer a very short reply. -2.86. In the year 2007, what is the difference between the Value added (% of GDP) of Hong Kong and Value added (% of GDP) of New Zealand?
Make the answer very short. -18.01. In the year 2007, what is the difference between the Value added (% of GDP) in Hong Kong and Value added (% of GDP) in Tonga?
Offer a terse response. -11.99. In the year 2007, what is the difference between the Value added (% of GDP) in New Zealand and Value added (% of GDP) in Tonga?
Your response must be concise. 6.01. In the year 2008, what is the difference between the Value added (% of GDP) of Dominica and Value added (% of GDP) of Hong Kong?
Provide a succinct answer. 8.24. In the year 2008, what is the difference between the Value added (% of GDP) of Dominica and Value added (% of GDP) of New Zealand?
Offer a terse response. -10.15. In the year 2008, what is the difference between the Value added (% of GDP) of Dominica and Value added (% of GDP) of Tonga?
Make the answer very short. -3.15. In the year 2008, what is the difference between the Value added (% of GDP) of Hong Kong and Value added (% of GDP) of New Zealand?
Make the answer very short. -18.4. In the year 2008, what is the difference between the Value added (% of GDP) in Hong Kong and Value added (% of GDP) in Tonga?
Provide a short and direct response. -11.4. In the year 2008, what is the difference between the Value added (% of GDP) of New Zealand and Value added (% of GDP) of Tonga?
Offer a terse response. 7. In the year 2009, what is the difference between the Value added (% of GDP) in Dominica and Value added (% of GDP) in Hong Kong?
Your answer should be very brief. 6.68. In the year 2009, what is the difference between the Value added (% of GDP) of Dominica and Value added (% of GDP) of New Zealand?
Your answer should be very brief. -10.61. In the year 2009, what is the difference between the Value added (% of GDP) in Dominica and Value added (% of GDP) in Tonga?
Make the answer very short. -5.62. In the year 2009, what is the difference between the Value added (% of GDP) of Hong Kong and Value added (% of GDP) of New Zealand?
Provide a succinct answer. -17.29. In the year 2009, what is the difference between the Value added (% of GDP) in Hong Kong and Value added (% of GDP) in Tonga?
Provide a succinct answer. -12.31. In the year 2009, what is the difference between the Value added (% of GDP) of New Zealand and Value added (% of GDP) of Tonga?
Provide a succinct answer. 4.99. In the year 2010, what is the difference between the Value added (% of GDP) of Dominica and Value added (% of GDP) of Hong Kong?
Keep it short and to the point. 7.09. In the year 2010, what is the difference between the Value added (% of GDP) in Dominica and Value added (% of GDP) in New Zealand?
Your answer should be compact. -9.46. In the year 2010, what is the difference between the Value added (% of GDP) of Dominica and Value added (% of GDP) of Tonga?
Ensure brevity in your answer.  -6.41. In the year 2010, what is the difference between the Value added (% of GDP) in Hong Kong and Value added (% of GDP) in New Zealand?
Ensure brevity in your answer.  -16.55. In the year 2010, what is the difference between the Value added (% of GDP) in Hong Kong and Value added (% of GDP) in Tonga?
Make the answer very short. -13.5. In the year 2010, what is the difference between the Value added (% of GDP) in New Zealand and Value added (% of GDP) in Tonga?
Provide a short and direct response. 3.05. What is the ratio of the Value added (% of GDP) in Dominica in 2003 to that in 2004?
Your answer should be very brief. 1.01. What is the ratio of the Value added (% of GDP) of Hong Kong in 2003 to that in 2004?
Offer a very short reply. 1.07. What is the ratio of the Value added (% of GDP) in New Zealand in 2003 to that in 2004?
Your answer should be very brief. 0.98. What is the ratio of the Value added (% of GDP) in Tonga in 2003 to that in 2004?
Make the answer very short. 1.03. What is the ratio of the Value added (% of GDP) in Dominica in 2003 to that in 2005?
Provide a succinct answer. 1.01. What is the ratio of the Value added (% of GDP) of Hong Kong in 2003 to that in 2005?
Give a very brief answer. 1.16. What is the ratio of the Value added (% of GDP) in New Zealand in 2003 to that in 2005?
Your response must be concise. 0.97. What is the ratio of the Value added (% of GDP) in Tonga in 2003 to that in 2005?
Your answer should be very brief. 1.02. What is the ratio of the Value added (% of GDP) of Dominica in 2003 to that in 2006?
Offer a terse response. 0.97. What is the ratio of the Value added (% of GDP) in Hong Kong in 2003 to that in 2006?
Offer a very short reply. 1.22. What is the ratio of the Value added (% of GDP) in Tonga in 2003 to that in 2006?
Your response must be concise. 1.1. What is the ratio of the Value added (% of GDP) of Dominica in 2003 to that in 2007?
Provide a short and direct response. 0.94. What is the ratio of the Value added (% of GDP) in Hong Kong in 2003 to that in 2007?
Give a very brief answer. 1.4. What is the ratio of the Value added (% of GDP) of Tonga in 2003 to that in 2007?
Your answer should be compact. 1.06. What is the ratio of the Value added (% of GDP) in Dominica in 2003 to that in 2008?
Your response must be concise. 0.99. What is the ratio of the Value added (% of GDP) in Hong Kong in 2003 to that in 2008?
Your answer should be compact. 1.39. What is the ratio of the Value added (% of GDP) in Tonga in 2003 to that in 2008?
Offer a very short reply. 1.09. What is the ratio of the Value added (% of GDP) in Dominica in 2003 to that in 2009?
Your response must be concise. 1.11. What is the ratio of the Value added (% of GDP) in Hong Kong in 2003 to that in 2009?
Provide a short and direct response. 1.42. What is the ratio of the Value added (% of GDP) of New Zealand in 2003 to that in 2009?
Provide a succinct answer. 1.02. What is the ratio of the Value added (% of GDP) of Tonga in 2003 to that in 2009?
Offer a terse response. 1.05. What is the ratio of the Value added (% of GDP) in Dominica in 2003 to that in 2010?
Your answer should be compact. 1.07. What is the ratio of the Value added (% of GDP) of Hong Kong in 2003 to that in 2010?
Ensure brevity in your answer.  1.42. What is the ratio of the Value added (% of GDP) of New Zealand in 2003 to that in 2010?
Give a very brief answer. 1.06. What is the ratio of the Value added (% of GDP) in Tonga in 2003 to that in 2010?
Give a very brief answer. 0.99. What is the ratio of the Value added (% of GDP) in Dominica in 2004 to that in 2005?
Your answer should be compact. 1. What is the ratio of the Value added (% of GDP) in Hong Kong in 2004 to that in 2005?
Give a very brief answer. 1.08. What is the ratio of the Value added (% of GDP) of New Zealand in 2004 to that in 2005?
Keep it short and to the point. 0.98. What is the ratio of the Value added (% of GDP) in Dominica in 2004 to that in 2006?
Provide a short and direct response. 0.96. What is the ratio of the Value added (% of GDP) of Hong Kong in 2004 to that in 2006?
Provide a succinct answer. 1.15. What is the ratio of the Value added (% of GDP) in New Zealand in 2004 to that in 2006?
Give a very brief answer. 1.01. What is the ratio of the Value added (% of GDP) of Tonga in 2004 to that in 2006?
Ensure brevity in your answer.  1.07. What is the ratio of the Value added (% of GDP) in Dominica in 2004 to that in 2007?
Ensure brevity in your answer.  0.93. What is the ratio of the Value added (% of GDP) in Hong Kong in 2004 to that in 2007?
Offer a terse response. 1.31. What is the ratio of the Value added (% of GDP) of New Zealand in 2004 to that in 2007?
Ensure brevity in your answer.  1.01. What is the ratio of the Value added (% of GDP) in Tonga in 2004 to that in 2007?
Your answer should be compact. 1.03. What is the ratio of the Value added (% of GDP) of Dominica in 2004 to that in 2008?
Your response must be concise. 0.98. What is the ratio of the Value added (% of GDP) in Hong Kong in 2004 to that in 2008?
Your answer should be compact. 1.3. What is the ratio of the Value added (% of GDP) of New Zealand in 2004 to that in 2008?
Your response must be concise. 0.99. What is the ratio of the Value added (% of GDP) in Tonga in 2004 to that in 2008?
Ensure brevity in your answer.  1.06. What is the ratio of the Value added (% of GDP) in Dominica in 2004 to that in 2009?
Ensure brevity in your answer.  1.1. What is the ratio of the Value added (% of GDP) of Hong Kong in 2004 to that in 2009?
Offer a terse response. 1.32. What is the ratio of the Value added (% of GDP) in New Zealand in 2004 to that in 2009?
Make the answer very short. 1.04. What is the ratio of the Value added (% of GDP) of Tonga in 2004 to that in 2009?
Your answer should be compact. 1.02. What is the ratio of the Value added (% of GDP) of Dominica in 2004 to that in 2010?
Your response must be concise. 1.07. What is the ratio of the Value added (% of GDP) in Hong Kong in 2004 to that in 2010?
Ensure brevity in your answer.  1.32. What is the ratio of the Value added (% of GDP) of New Zealand in 2004 to that in 2010?
Your answer should be very brief. 1.07. What is the ratio of the Value added (% of GDP) of Tonga in 2004 to that in 2010?
Keep it short and to the point. 0.96. What is the ratio of the Value added (% of GDP) in Hong Kong in 2005 to that in 2006?
Make the answer very short. 1.06. What is the ratio of the Value added (% of GDP) of New Zealand in 2005 to that in 2006?
Your answer should be compact. 1.02. What is the ratio of the Value added (% of GDP) of Tonga in 2005 to that in 2006?
Your answer should be very brief. 1.08. What is the ratio of the Value added (% of GDP) in Dominica in 2005 to that in 2007?
Provide a succinct answer. 0.93. What is the ratio of the Value added (% of GDP) of Hong Kong in 2005 to that in 2007?
Your answer should be compact. 1.21. What is the ratio of the Value added (% of GDP) of New Zealand in 2005 to that in 2007?
Make the answer very short. 1.03. What is the ratio of the Value added (% of GDP) of Tonga in 2005 to that in 2007?
Give a very brief answer. 1.04. What is the ratio of the Value added (% of GDP) in Dominica in 2005 to that in 2008?
Your response must be concise. 0.97. What is the ratio of the Value added (% of GDP) in Hong Kong in 2005 to that in 2008?
Keep it short and to the point. 1.2. What is the ratio of the Value added (% of GDP) in Tonga in 2005 to that in 2008?
Your response must be concise. 1.07. What is the ratio of the Value added (% of GDP) of Dominica in 2005 to that in 2009?
Your answer should be very brief. 1.09. What is the ratio of the Value added (% of GDP) of Hong Kong in 2005 to that in 2009?
Ensure brevity in your answer.  1.22. What is the ratio of the Value added (% of GDP) of New Zealand in 2005 to that in 2009?
Make the answer very short. 1.06. What is the ratio of the Value added (% of GDP) in Tonga in 2005 to that in 2009?
Your answer should be compact. 1.03. What is the ratio of the Value added (% of GDP) in Dominica in 2005 to that in 2010?
Your answer should be very brief. 1.06. What is the ratio of the Value added (% of GDP) in Hong Kong in 2005 to that in 2010?
Ensure brevity in your answer.  1.22. What is the ratio of the Value added (% of GDP) of New Zealand in 2005 to that in 2010?
Offer a terse response. 1.09. What is the ratio of the Value added (% of GDP) of Tonga in 2005 to that in 2010?
Your response must be concise. 0.97. What is the ratio of the Value added (% of GDP) in Dominica in 2006 to that in 2007?
Give a very brief answer. 0.96. What is the ratio of the Value added (% of GDP) in Hong Kong in 2006 to that in 2007?
Offer a very short reply. 1.15. What is the ratio of the Value added (% of GDP) in New Zealand in 2006 to that in 2007?
Offer a terse response. 1. What is the ratio of the Value added (% of GDP) of Tonga in 2006 to that in 2007?
Provide a succinct answer. 0.97. What is the ratio of the Value added (% of GDP) of Dominica in 2006 to that in 2008?
Your answer should be compact. 1.01. What is the ratio of the Value added (% of GDP) of Hong Kong in 2006 to that in 2008?
Your answer should be very brief. 1.13. What is the ratio of the Value added (% of GDP) of New Zealand in 2006 to that in 2008?
Your answer should be compact. 0.98. What is the ratio of the Value added (% of GDP) in Tonga in 2006 to that in 2008?
Ensure brevity in your answer.  0.99. What is the ratio of the Value added (% of GDP) of Dominica in 2006 to that in 2009?
Provide a short and direct response. 1.14. What is the ratio of the Value added (% of GDP) in Hong Kong in 2006 to that in 2009?
Provide a succinct answer. 1.16. What is the ratio of the Value added (% of GDP) of New Zealand in 2006 to that in 2009?
Ensure brevity in your answer.  1.03. What is the ratio of the Value added (% of GDP) in Tonga in 2006 to that in 2009?
Give a very brief answer. 0.95. What is the ratio of the Value added (% of GDP) in Dominica in 2006 to that in 2010?
Your answer should be compact. 1.11. What is the ratio of the Value added (% of GDP) in Hong Kong in 2006 to that in 2010?
Your answer should be very brief. 1.16. What is the ratio of the Value added (% of GDP) in New Zealand in 2006 to that in 2010?
Ensure brevity in your answer.  1.07. What is the ratio of the Value added (% of GDP) in Tonga in 2006 to that in 2010?
Provide a short and direct response. 0.9. What is the ratio of the Value added (% of GDP) of Dominica in 2007 to that in 2008?
Your answer should be very brief. 1.05. What is the ratio of the Value added (% of GDP) in Hong Kong in 2007 to that in 2008?
Ensure brevity in your answer.  0.99. What is the ratio of the Value added (% of GDP) in New Zealand in 2007 to that in 2008?
Your answer should be very brief. 0.98. What is the ratio of the Value added (% of GDP) in Tonga in 2007 to that in 2008?
Offer a very short reply. 1.03. What is the ratio of the Value added (% of GDP) in Dominica in 2007 to that in 2009?
Provide a short and direct response. 1.18. What is the ratio of the Value added (% of GDP) in Hong Kong in 2007 to that in 2009?
Offer a very short reply. 1.01. What is the ratio of the Value added (% of GDP) of New Zealand in 2007 to that in 2009?
Provide a succinct answer. 1.03. What is the ratio of the Value added (% of GDP) of Tonga in 2007 to that in 2009?
Offer a very short reply. 0.99. What is the ratio of the Value added (% of GDP) of Dominica in 2007 to that in 2010?
Your answer should be compact. 1.15. What is the ratio of the Value added (% of GDP) in Hong Kong in 2007 to that in 2010?
Give a very brief answer. 1.01. What is the ratio of the Value added (% of GDP) in New Zealand in 2007 to that in 2010?
Keep it short and to the point. 1.06. What is the ratio of the Value added (% of GDP) in Tonga in 2007 to that in 2010?
Your response must be concise. 0.93. What is the ratio of the Value added (% of GDP) of Dominica in 2008 to that in 2009?
Provide a succinct answer. 1.12. What is the ratio of the Value added (% of GDP) of Hong Kong in 2008 to that in 2009?
Your answer should be very brief. 1.02. What is the ratio of the Value added (% of GDP) in New Zealand in 2008 to that in 2009?
Provide a short and direct response. 1.05. What is the ratio of the Value added (% of GDP) of Tonga in 2008 to that in 2009?
Offer a terse response. 0.96. What is the ratio of the Value added (% of GDP) in Dominica in 2008 to that in 2010?
Provide a short and direct response. 1.09. What is the ratio of the Value added (% of GDP) of Hong Kong in 2008 to that in 2010?
Provide a succinct answer. 1.02. What is the ratio of the Value added (% of GDP) in New Zealand in 2008 to that in 2010?
Give a very brief answer. 1.08. What is the ratio of the Value added (% of GDP) of Tonga in 2008 to that in 2010?
Make the answer very short. 0.9. What is the ratio of the Value added (% of GDP) in Dominica in 2009 to that in 2010?
Your answer should be compact. 0.97. What is the ratio of the Value added (% of GDP) in New Zealand in 2009 to that in 2010?
Your answer should be compact. 1.03. What is the ratio of the Value added (% of GDP) in Tonga in 2009 to that in 2010?
Provide a short and direct response. 0.94. What is the difference between the highest and the second highest Value added (% of GDP) of Dominica?
Offer a terse response. 0.6. What is the difference between the highest and the second highest Value added (% of GDP) in Hong Kong?
Give a very brief answer. 0.65. What is the difference between the highest and the second highest Value added (% of GDP) in New Zealand?
Your response must be concise. 0.18. What is the difference between the highest and the second highest Value added (% of GDP) in Tonga?
Keep it short and to the point. 0.31. What is the difference between the highest and the lowest Value added (% of GDP) in Dominica?
Offer a very short reply. 2.52. What is the difference between the highest and the lowest Value added (% of GDP) of Hong Kong?
Make the answer very short. 2.96. What is the difference between the highest and the lowest Value added (% of GDP) of New Zealand?
Provide a succinct answer. 2.16. What is the difference between the highest and the lowest Value added (% of GDP) in Tonga?
Make the answer very short. 2.11. 